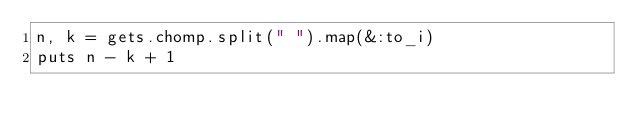Convert code to text. <code><loc_0><loc_0><loc_500><loc_500><_Ruby_>n, k = gets.chomp.split(" ").map(&:to_i)
puts n - k + 1
</code> 